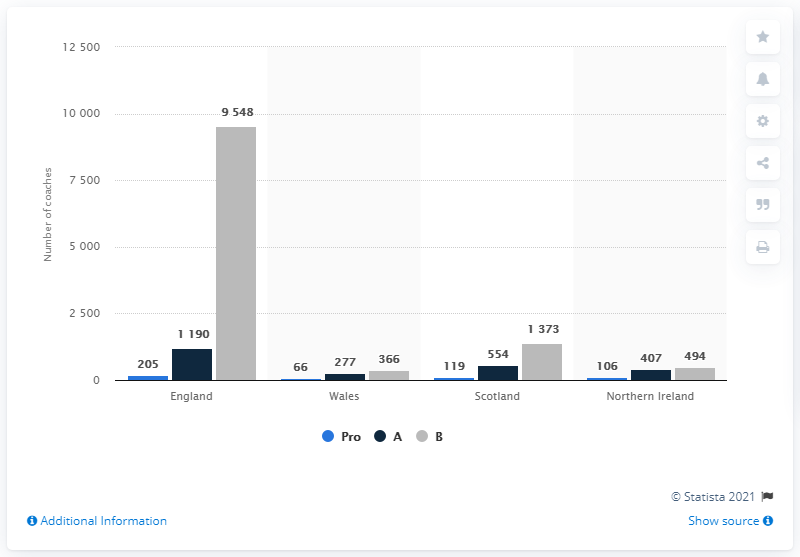Point out several critical features in this image. In 2013, there were 205 football coaches in England. 